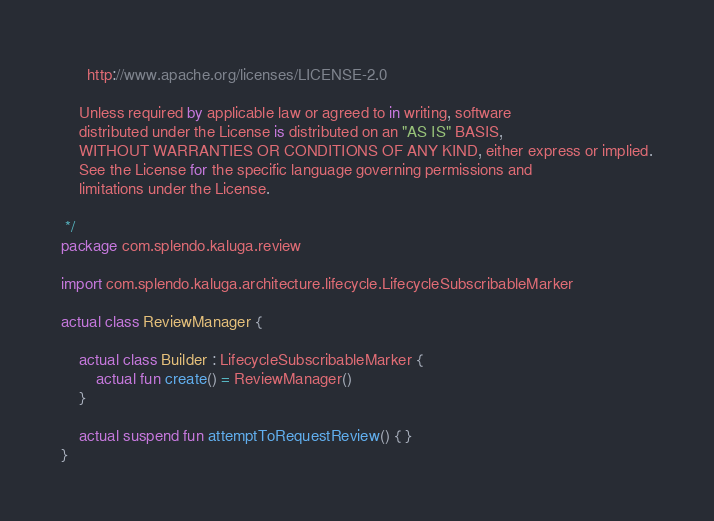<code> <loc_0><loc_0><loc_500><loc_500><_Kotlin_>
      http://www.apache.org/licenses/LICENSE-2.0

    Unless required by applicable law or agreed to in writing, software
    distributed under the License is distributed on an "AS IS" BASIS,
    WITHOUT WARRANTIES OR CONDITIONS OF ANY KIND, either express or implied.
    See the License for the specific language governing permissions and
    limitations under the License.

 */
package com.splendo.kaluga.review

import com.splendo.kaluga.architecture.lifecycle.LifecycleSubscribableMarker

actual class ReviewManager {

    actual class Builder : LifecycleSubscribableMarker {
        actual fun create() = ReviewManager()
    }

    actual suspend fun attemptToRequestReview() { }
}
</code> 